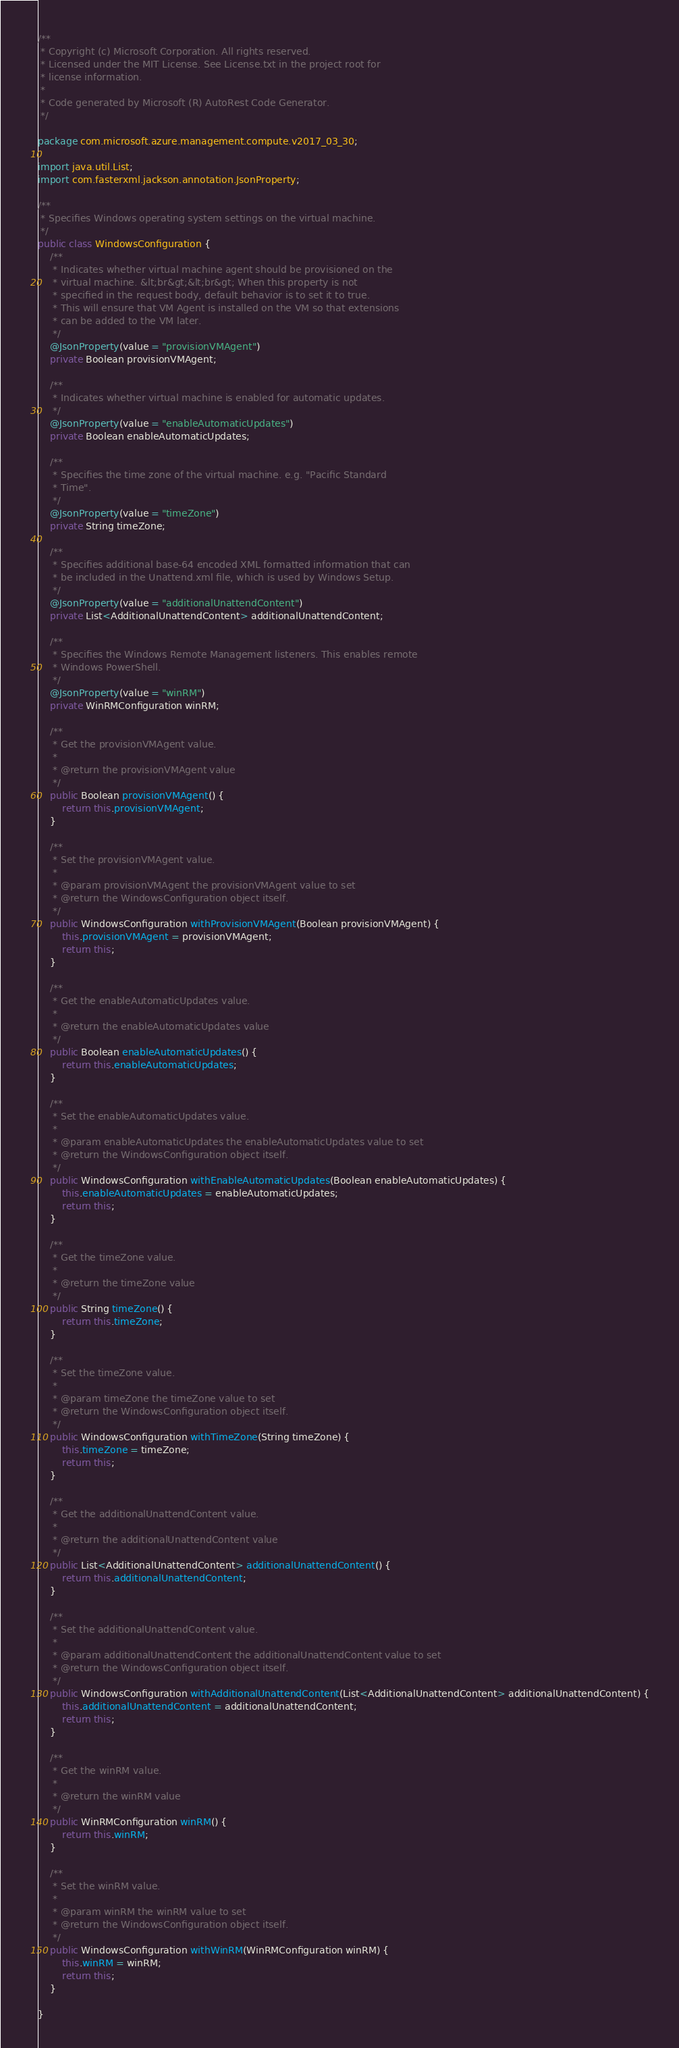<code> <loc_0><loc_0><loc_500><loc_500><_Java_>/**
 * Copyright (c) Microsoft Corporation. All rights reserved.
 * Licensed under the MIT License. See License.txt in the project root for
 * license information.
 *
 * Code generated by Microsoft (R) AutoRest Code Generator.
 */

package com.microsoft.azure.management.compute.v2017_03_30;

import java.util.List;
import com.fasterxml.jackson.annotation.JsonProperty;

/**
 * Specifies Windows operating system settings on the virtual machine.
 */
public class WindowsConfiguration {
    /**
     * Indicates whether virtual machine agent should be provisioned on the
     * virtual machine. &lt;br&gt;&lt;br&gt; When this property is not
     * specified in the request body, default behavior is to set it to true.
     * This will ensure that VM Agent is installed on the VM so that extensions
     * can be added to the VM later.
     */
    @JsonProperty(value = "provisionVMAgent")
    private Boolean provisionVMAgent;

    /**
     * Indicates whether virtual machine is enabled for automatic updates.
     */
    @JsonProperty(value = "enableAutomaticUpdates")
    private Boolean enableAutomaticUpdates;

    /**
     * Specifies the time zone of the virtual machine. e.g. "Pacific Standard
     * Time".
     */
    @JsonProperty(value = "timeZone")
    private String timeZone;

    /**
     * Specifies additional base-64 encoded XML formatted information that can
     * be included in the Unattend.xml file, which is used by Windows Setup.
     */
    @JsonProperty(value = "additionalUnattendContent")
    private List<AdditionalUnattendContent> additionalUnattendContent;

    /**
     * Specifies the Windows Remote Management listeners. This enables remote
     * Windows PowerShell.
     */
    @JsonProperty(value = "winRM")
    private WinRMConfiguration winRM;

    /**
     * Get the provisionVMAgent value.
     *
     * @return the provisionVMAgent value
     */
    public Boolean provisionVMAgent() {
        return this.provisionVMAgent;
    }

    /**
     * Set the provisionVMAgent value.
     *
     * @param provisionVMAgent the provisionVMAgent value to set
     * @return the WindowsConfiguration object itself.
     */
    public WindowsConfiguration withProvisionVMAgent(Boolean provisionVMAgent) {
        this.provisionVMAgent = provisionVMAgent;
        return this;
    }

    /**
     * Get the enableAutomaticUpdates value.
     *
     * @return the enableAutomaticUpdates value
     */
    public Boolean enableAutomaticUpdates() {
        return this.enableAutomaticUpdates;
    }

    /**
     * Set the enableAutomaticUpdates value.
     *
     * @param enableAutomaticUpdates the enableAutomaticUpdates value to set
     * @return the WindowsConfiguration object itself.
     */
    public WindowsConfiguration withEnableAutomaticUpdates(Boolean enableAutomaticUpdates) {
        this.enableAutomaticUpdates = enableAutomaticUpdates;
        return this;
    }

    /**
     * Get the timeZone value.
     *
     * @return the timeZone value
     */
    public String timeZone() {
        return this.timeZone;
    }

    /**
     * Set the timeZone value.
     *
     * @param timeZone the timeZone value to set
     * @return the WindowsConfiguration object itself.
     */
    public WindowsConfiguration withTimeZone(String timeZone) {
        this.timeZone = timeZone;
        return this;
    }

    /**
     * Get the additionalUnattendContent value.
     *
     * @return the additionalUnattendContent value
     */
    public List<AdditionalUnattendContent> additionalUnattendContent() {
        return this.additionalUnattendContent;
    }

    /**
     * Set the additionalUnattendContent value.
     *
     * @param additionalUnattendContent the additionalUnattendContent value to set
     * @return the WindowsConfiguration object itself.
     */
    public WindowsConfiguration withAdditionalUnattendContent(List<AdditionalUnattendContent> additionalUnattendContent) {
        this.additionalUnattendContent = additionalUnattendContent;
        return this;
    }

    /**
     * Get the winRM value.
     *
     * @return the winRM value
     */
    public WinRMConfiguration winRM() {
        return this.winRM;
    }

    /**
     * Set the winRM value.
     *
     * @param winRM the winRM value to set
     * @return the WindowsConfiguration object itself.
     */
    public WindowsConfiguration withWinRM(WinRMConfiguration winRM) {
        this.winRM = winRM;
        return this;
    }

}
</code> 